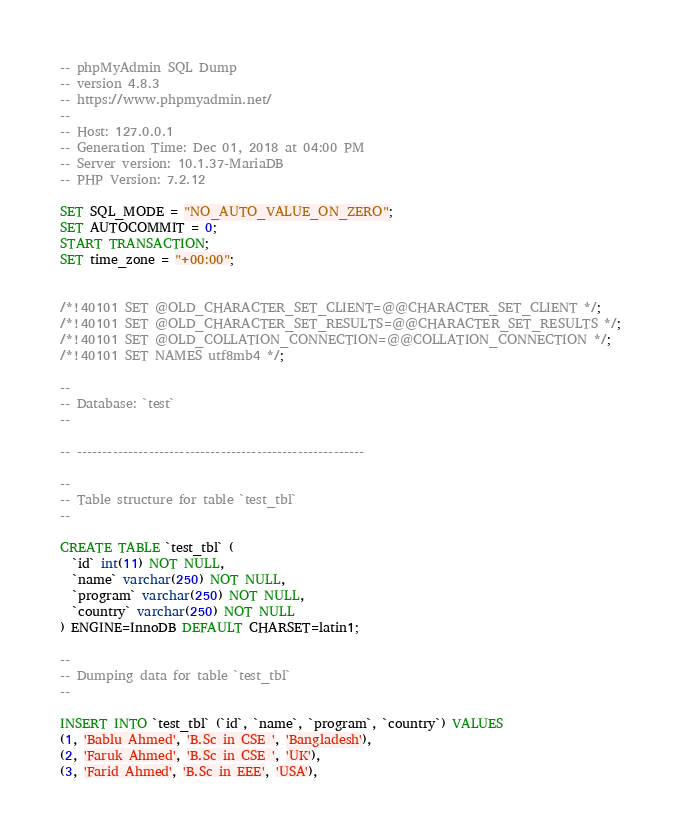<code> <loc_0><loc_0><loc_500><loc_500><_SQL_>-- phpMyAdmin SQL Dump
-- version 4.8.3
-- https://www.phpmyadmin.net/
--
-- Host: 127.0.0.1
-- Generation Time: Dec 01, 2018 at 04:00 PM
-- Server version: 10.1.37-MariaDB
-- PHP Version: 7.2.12

SET SQL_MODE = "NO_AUTO_VALUE_ON_ZERO";
SET AUTOCOMMIT = 0;
START TRANSACTION;
SET time_zone = "+00:00";


/*!40101 SET @OLD_CHARACTER_SET_CLIENT=@@CHARACTER_SET_CLIENT */;
/*!40101 SET @OLD_CHARACTER_SET_RESULTS=@@CHARACTER_SET_RESULTS */;
/*!40101 SET @OLD_COLLATION_CONNECTION=@@COLLATION_CONNECTION */;
/*!40101 SET NAMES utf8mb4 */;

--
-- Database: `test`
--

-- --------------------------------------------------------

--
-- Table structure for table `test_tbl`
--

CREATE TABLE `test_tbl` (
  `id` int(11) NOT NULL,
  `name` varchar(250) NOT NULL,
  `program` varchar(250) NOT NULL,
  `country` varchar(250) NOT NULL
) ENGINE=InnoDB DEFAULT CHARSET=latin1;

--
-- Dumping data for table `test_tbl`
--

INSERT INTO `test_tbl` (`id`, `name`, `program`, `country`) VALUES
(1, 'Bablu Ahmed', 'B.Sc in CSE ', 'Bangladesh'),
(2, 'Faruk Ahmed', 'B.Sc in CSE ', 'UK'),
(3, 'Farid Ahmed', 'B.Sc in EEE', 'USA'),</code> 